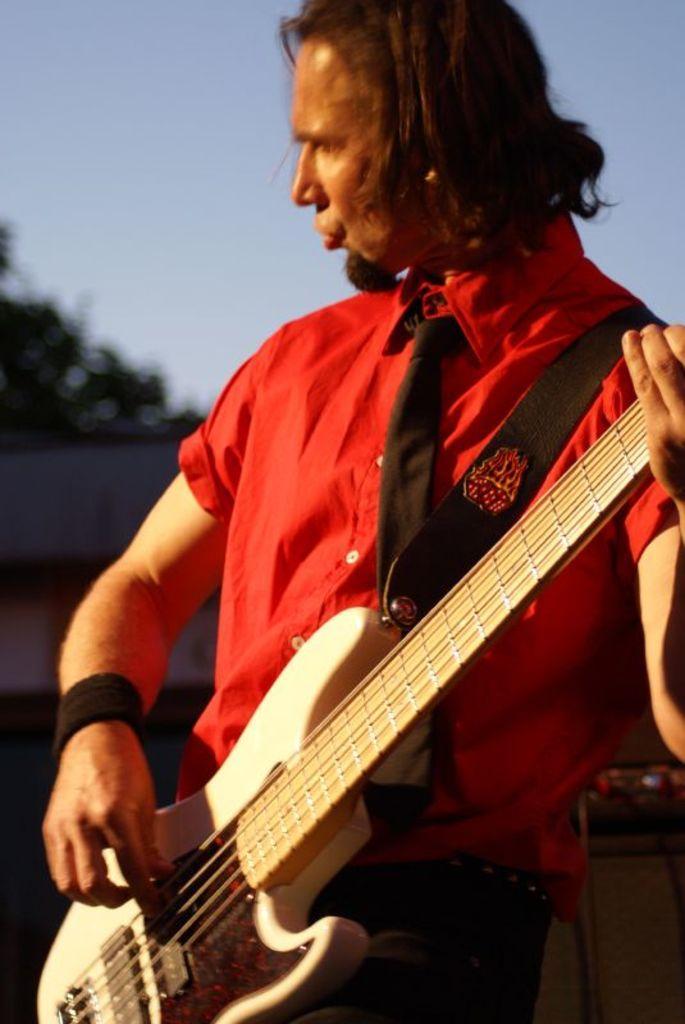Could you give a brief overview of what you see in this image? In this image I can see a person holding the guitar. In the background there is a sky. 